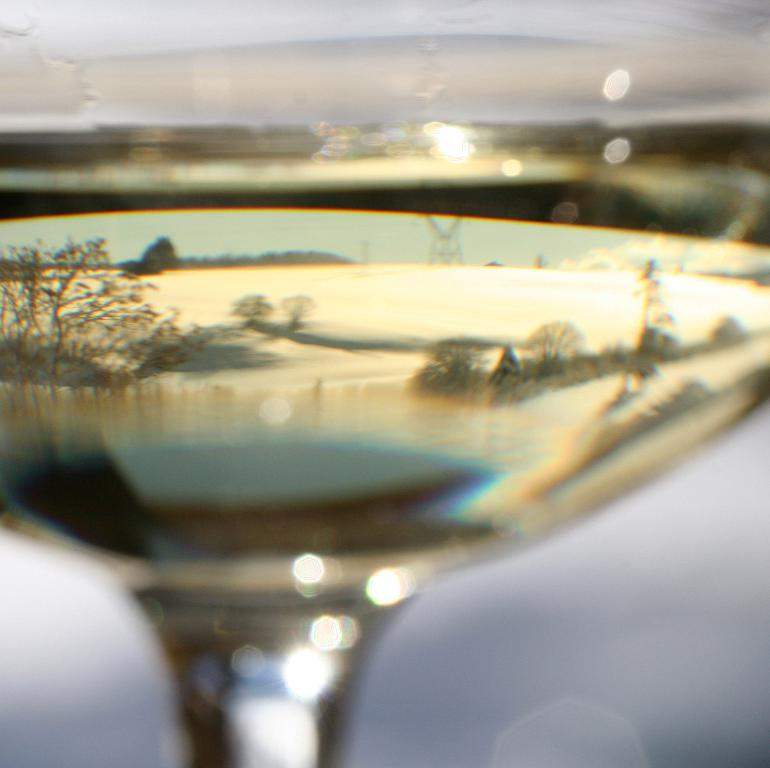What is in the image that is typically used for drinking? There is a wine glass in the image. What can be seen in the reflection of the wine glass? The wine glass has a reflection of trees and a river. What type of sweater is being worn by the idea in the image? There is no idea or person wearing a sweater present in the image; it only features a wine glass with a reflection. 